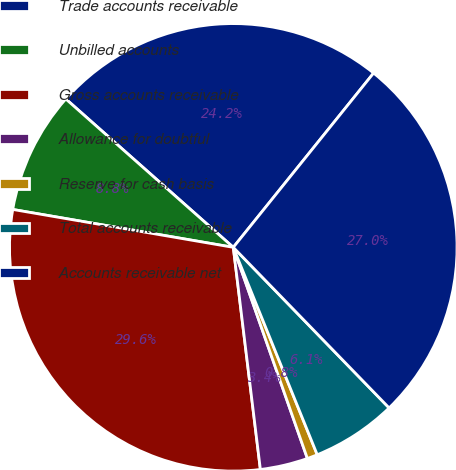<chart> <loc_0><loc_0><loc_500><loc_500><pie_chart><fcel>Trade accounts receivable<fcel>Unbilled accounts<fcel>Gross accounts receivable<fcel>Allowance for doubtful<fcel>Reserve for cash basis<fcel>Total accounts receivable<fcel>Accounts receivable net<nl><fcel>24.25%<fcel>8.83%<fcel>29.64%<fcel>3.44%<fcel>0.75%<fcel>6.14%<fcel>26.95%<nl></chart> 